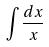<formula> <loc_0><loc_0><loc_500><loc_500>\int \frac { d x } { x }</formula> 